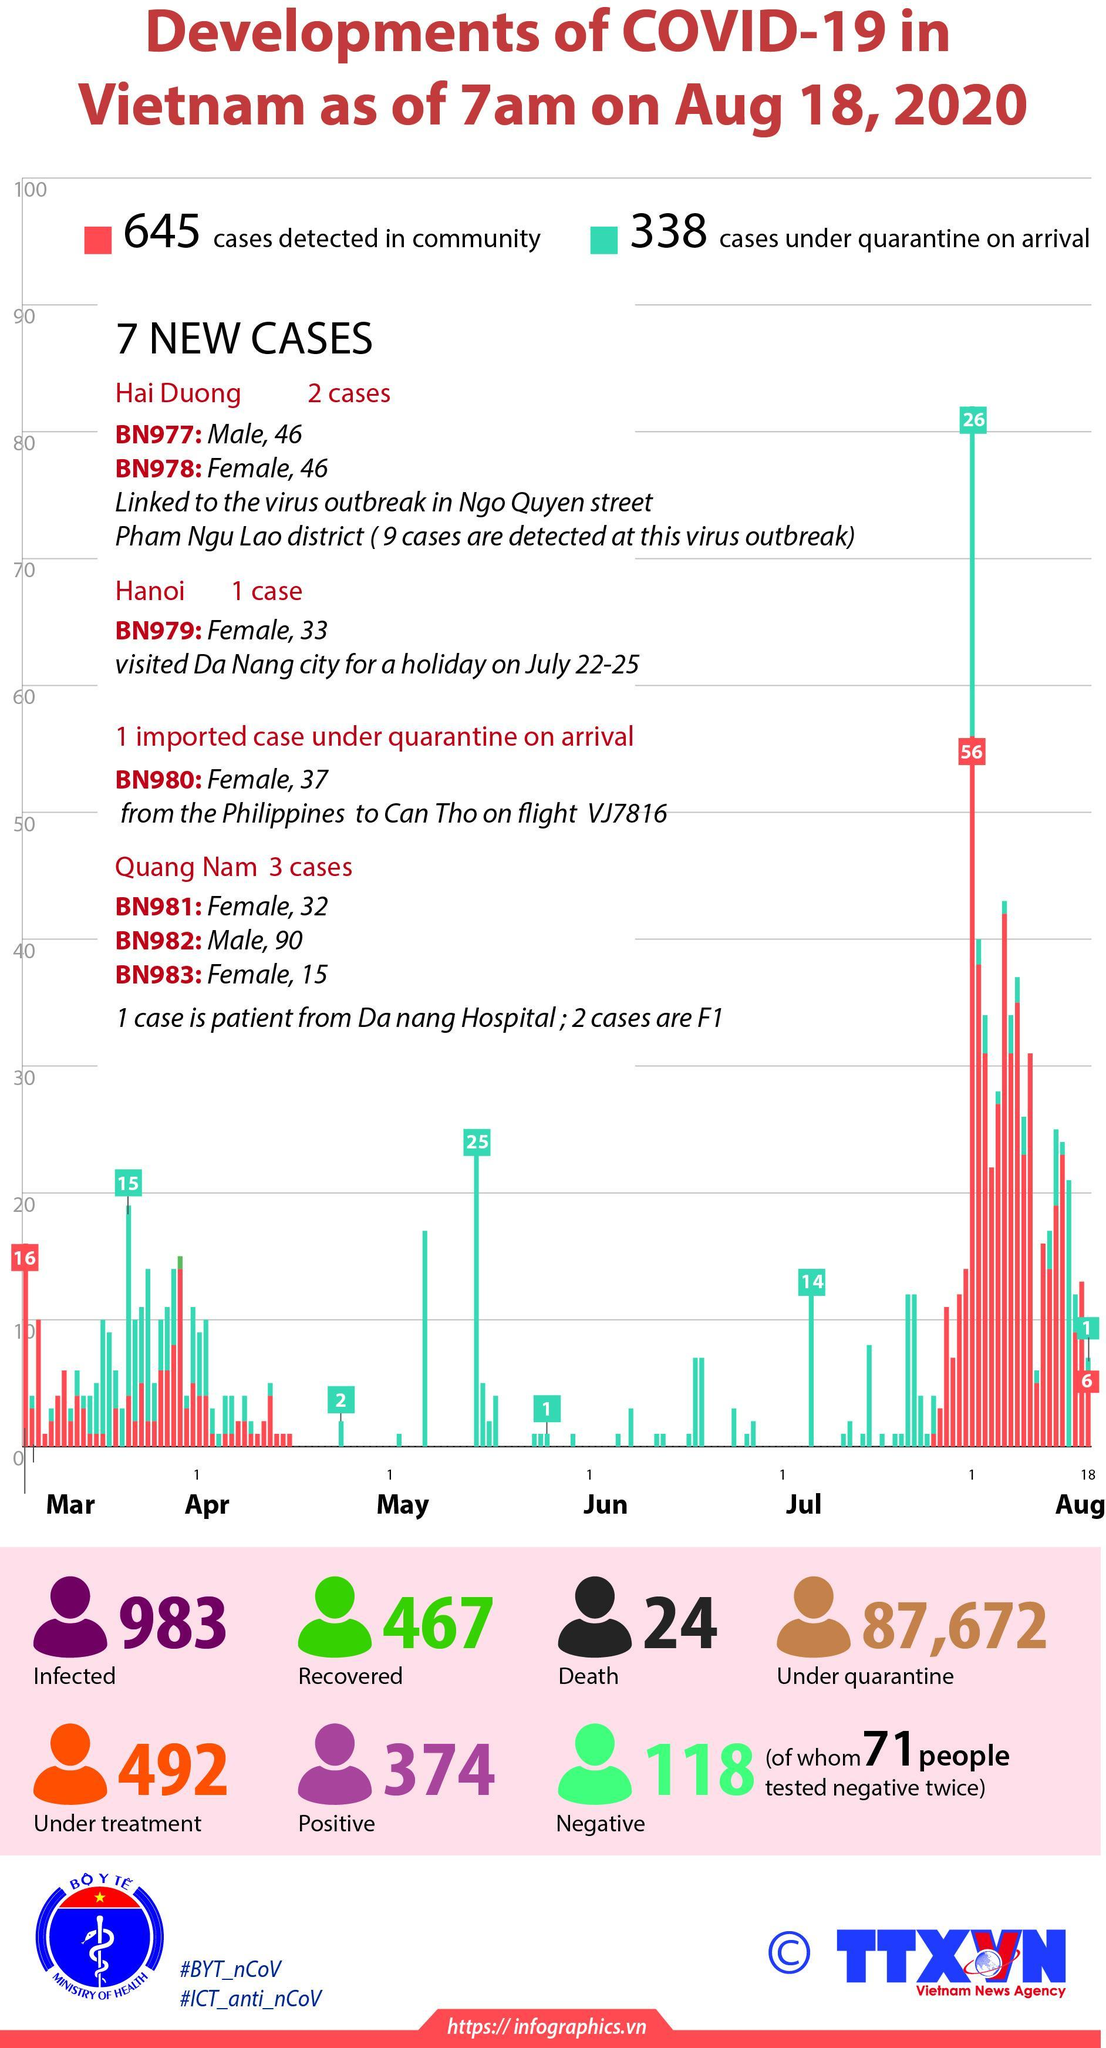How many people have got tested negative?
Answer the question with a short phrase. 118 How many people have not checked twice their result is negative? 47 How many cases are under quarantine on arrival in the month May- Jun? 26 How many people got infected with corona virus in Vietnam? 983 What is the no of people who are under quarantine in Vietnam? 87,672 How many people are Corona Positive as on Aug 18, 2020? 374 How many people got recovered from Corona virus in Vietnam? 467 What is the no of people who are under treatment? 492 How many people got died in Vietnam as on Aug 18, 2020? 24 